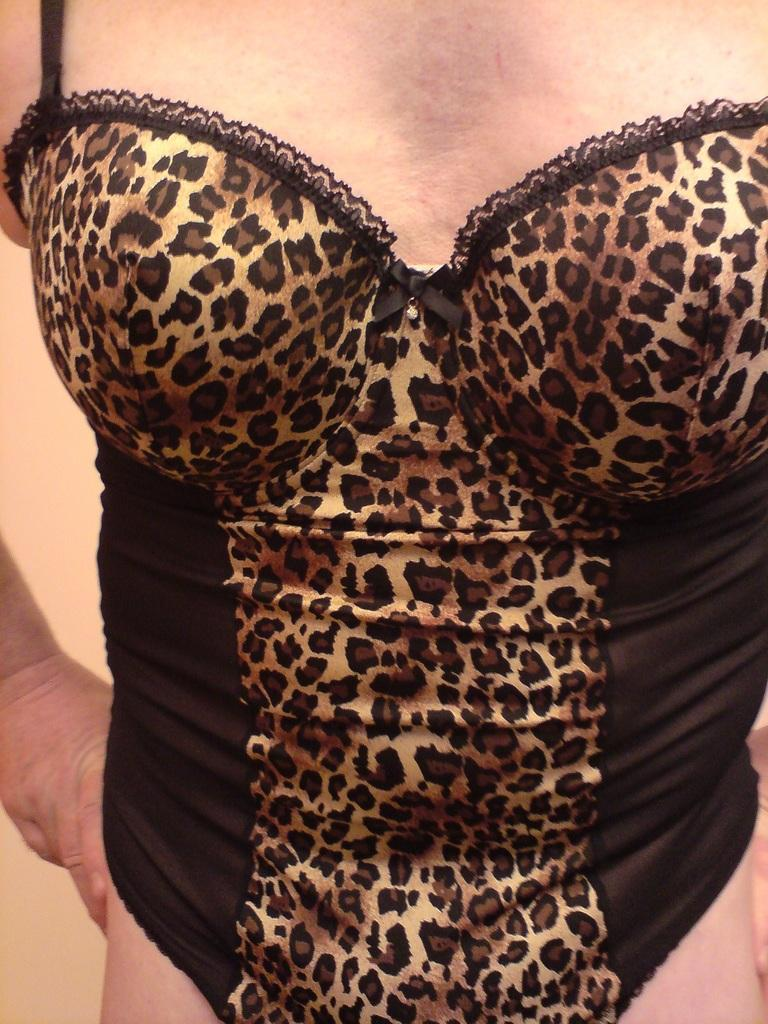What is present in the image? There is a person in the image. Can you describe the person's attire? The person is wearing a black dress. What type of wine is the person holding in the image? There is no wine present in the image; the person is wearing a black dress. Can you see a giraffe in the background of the image? There is no giraffe present in the image; it only features a person wearing a black dress. 